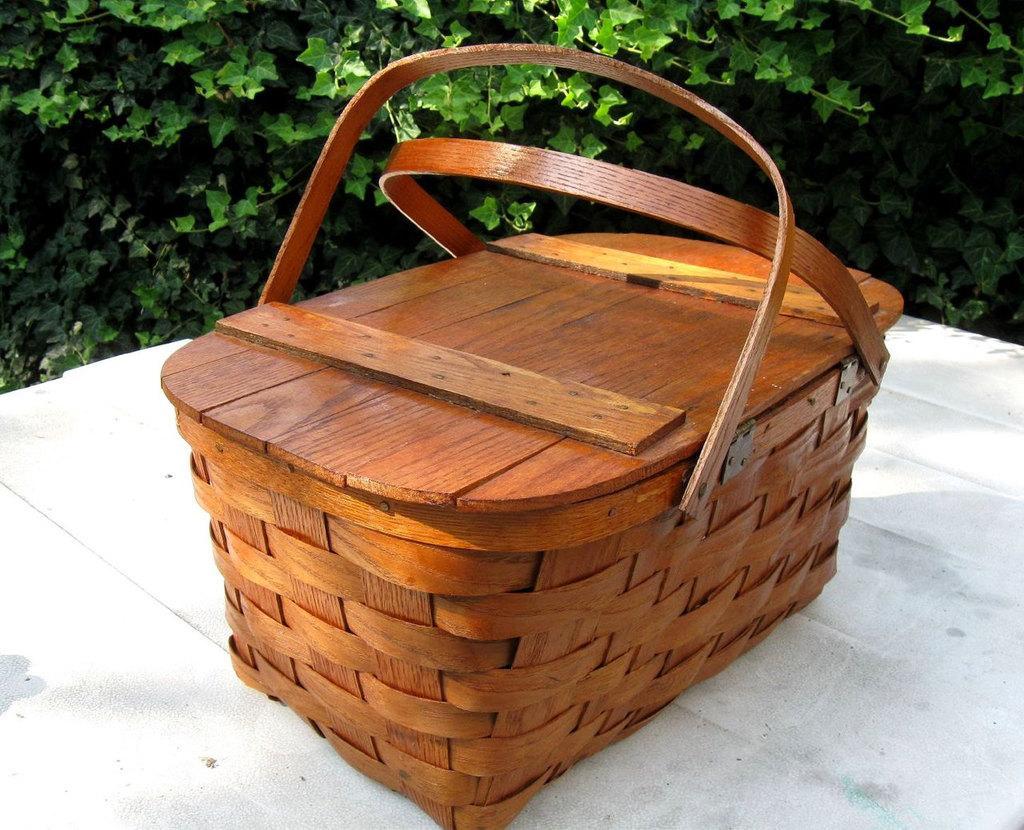How would you summarize this image in a sentence or two? This picture contains a brown basket with lid is placed on the white table. Behind that, we see plants which are green in color. 